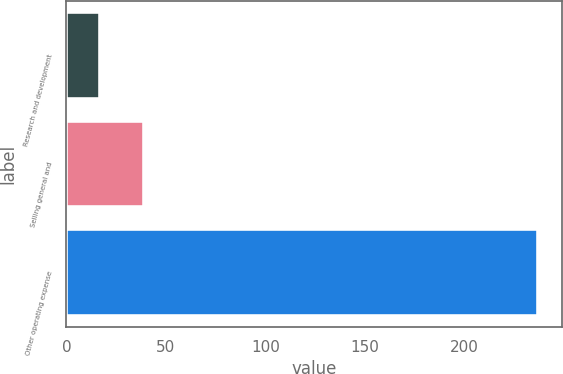<chart> <loc_0><loc_0><loc_500><loc_500><bar_chart><fcel>Research and development<fcel>Selling general and<fcel>Other operating expense<nl><fcel>17<fcel>39<fcel>237<nl></chart> 